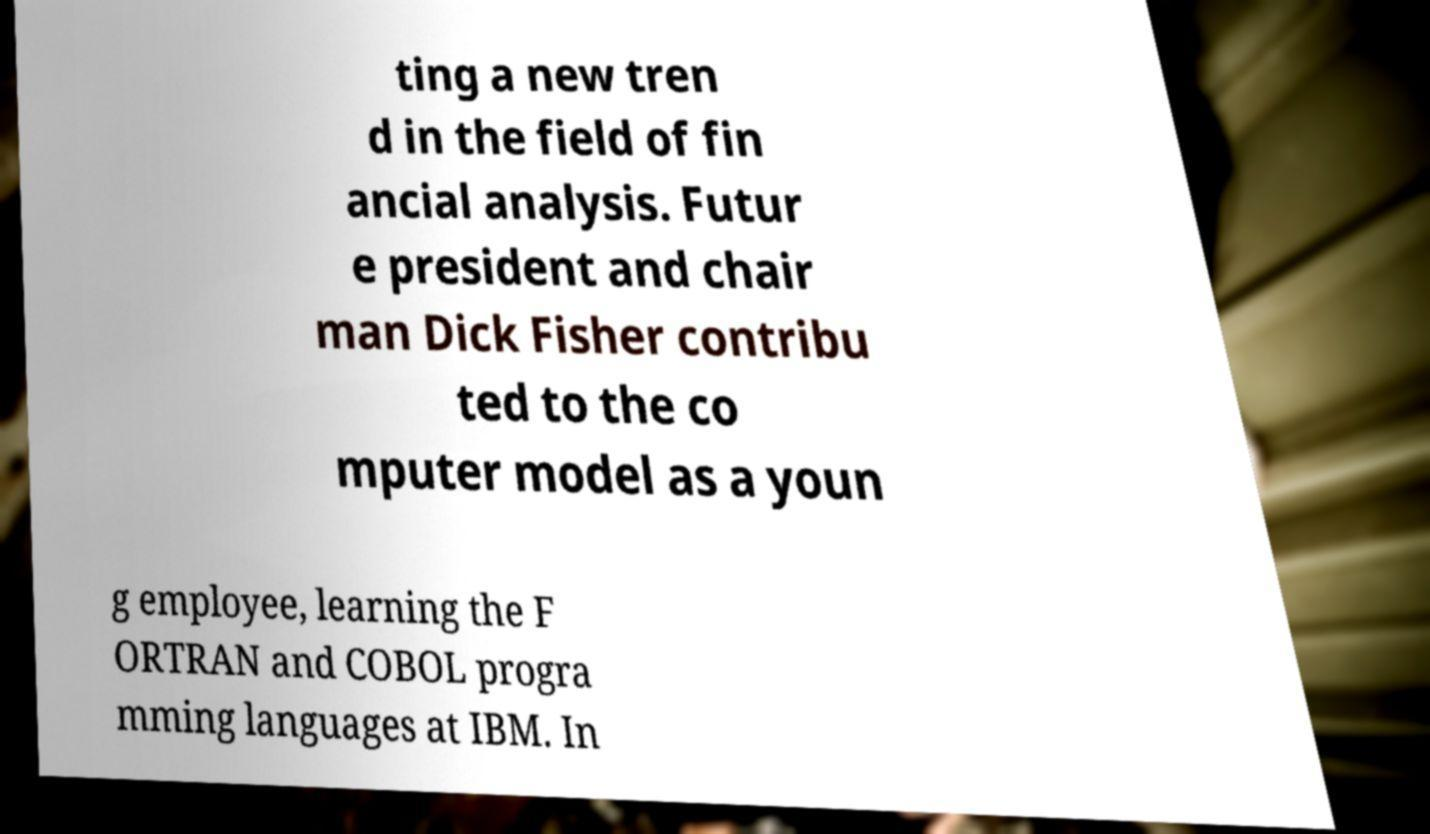What messages or text are displayed in this image? I need them in a readable, typed format. ting a new tren d in the field of fin ancial analysis. Futur e president and chair man Dick Fisher contribu ted to the co mputer model as a youn g employee, learning the F ORTRAN and COBOL progra mming languages at IBM. In 